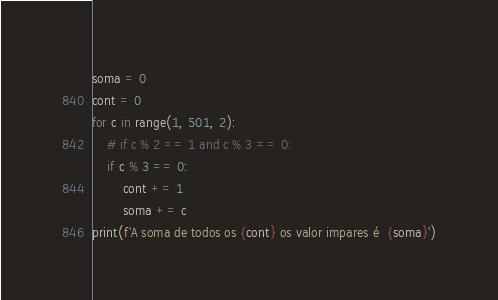<code> <loc_0><loc_0><loc_500><loc_500><_Python_>soma = 0
cont = 0
for c in range(1, 501, 2):
    # if c % 2 == 1 and c % 3 == 0:
    if c % 3 == 0:
        cont += 1
        soma += c
print(f'A soma de todos os {cont} os valor impares é  {soma}')
</code> 